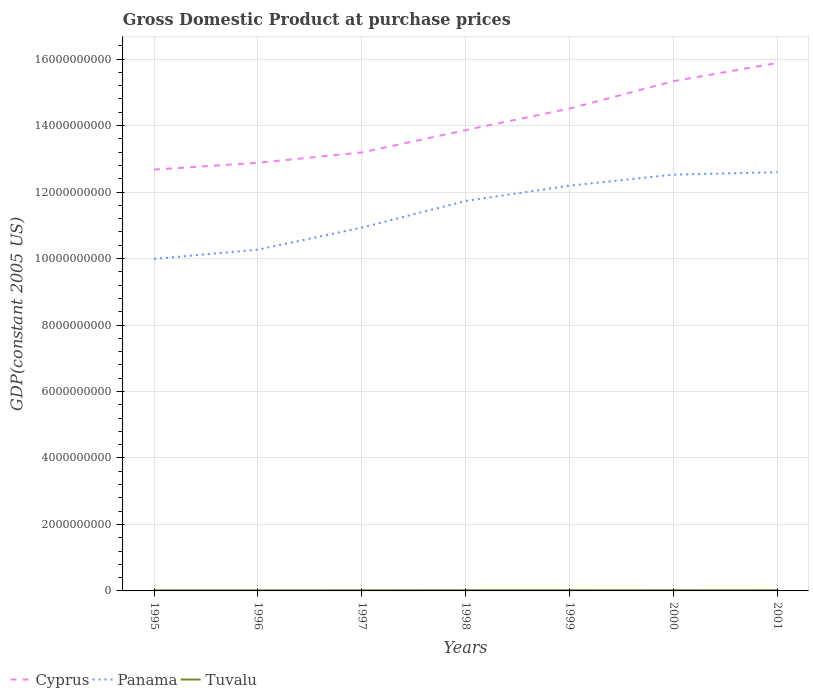How many different coloured lines are there?
Make the answer very short. 3. Across all years, what is the maximum GDP at purchase prices in Tuvalu?
Make the answer very short. 1.75e+07. In which year was the GDP at purchase prices in Cyprus maximum?
Your answer should be compact. 1995. What is the total GDP at purchase prices in Cyprus in the graph?
Your answer should be compact. -1.84e+09. What is the difference between the highest and the second highest GDP at purchase prices in Cyprus?
Your answer should be very brief. 3.21e+09. What is the difference between the highest and the lowest GDP at purchase prices in Cyprus?
Keep it short and to the point. 3. Is the GDP at purchase prices in Cyprus strictly greater than the GDP at purchase prices in Tuvalu over the years?
Provide a succinct answer. No. How many lines are there?
Make the answer very short. 3. How many years are there in the graph?
Your response must be concise. 7. Are the values on the major ticks of Y-axis written in scientific E-notation?
Offer a very short reply. No. Does the graph contain any zero values?
Offer a very short reply. No. Where does the legend appear in the graph?
Keep it short and to the point. Bottom left. What is the title of the graph?
Ensure brevity in your answer.  Gross Domestic Product at purchase prices. Does "Germany" appear as one of the legend labels in the graph?
Ensure brevity in your answer.  No. What is the label or title of the Y-axis?
Provide a short and direct response. GDP(constant 2005 US). What is the GDP(constant 2005 US) in Cyprus in 1995?
Provide a short and direct response. 1.27e+1. What is the GDP(constant 2005 US) of Panama in 1995?
Offer a very short reply. 9.99e+09. What is the GDP(constant 2005 US) of Tuvalu in 1995?
Your answer should be very brief. 1.86e+07. What is the GDP(constant 2005 US) in Cyprus in 1996?
Offer a terse response. 1.29e+1. What is the GDP(constant 2005 US) of Panama in 1996?
Your answer should be very brief. 1.03e+1. What is the GDP(constant 2005 US) in Tuvalu in 1996?
Give a very brief answer. 1.75e+07. What is the GDP(constant 2005 US) of Cyprus in 1997?
Provide a short and direct response. 1.32e+1. What is the GDP(constant 2005 US) of Panama in 1997?
Give a very brief answer. 1.09e+1. What is the GDP(constant 2005 US) in Tuvalu in 1997?
Provide a short and direct response. 1.93e+07. What is the GDP(constant 2005 US) of Cyprus in 1998?
Offer a very short reply. 1.39e+1. What is the GDP(constant 2005 US) in Panama in 1998?
Your answer should be very brief. 1.17e+1. What is the GDP(constant 2005 US) of Tuvalu in 1998?
Your response must be concise. 2.23e+07. What is the GDP(constant 2005 US) of Cyprus in 1999?
Offer a very short reply. 1.45e+1. What is the GDP(constant 2005 US) of Panama in 1999?
Provide a succinct answer. 1.22e+1. What is the GDP(constant 2005 US) of Tuvalu in 1999?
Ensure brevity in your answer.  2.19e+07. What is the GDP(constant 2005 US) in Cyprus in 2000?
Provide a succinct answer. 1.53e+1. What is the GDP(constant 2005 US) of Panama in 2000?
Make the answer very short. 1.25e+1. What is the GDP(constant 2005 US) of Tuvalu in 2000?
Offer a very short reply. 2.17e+07. What is the GDP(constant 2005 US) of Cyprus in 2001?
Provide a short and direct response. 1.59e+1. What is the GDP(constant 2005 US) in Panama in 2001?
Make the answer very short. 1.26e+1. What is the GDP(constant 2005 US) of Tuvalu in 2001?
Offer a terse response. 2.21e+07. Across all years, what is the maximum GDP(constant 2005 US) of Cyprus?
Make the answer very short. 1.59e+1. Across all years, what is the maximum GDP(constant 2005 US) in Panama?
Keep it short and to the point. 1.26e+1. Across all years, what is the maximum GDP(constant 2005 US) of Tuvalu?
Your response must be concise. 2.23e+07. Across all years, what is the minimum GDP(constant 2005 US) in Cyprus?
Provide a short and direct response. 1.27e+1. Across all years, what is the minimum GDP(constant 2005 US) in Panama?
Provide a short and direct response. 9.99e+09. Across all years, what is the minimum GDP(constant 2005 US) in Tuvalu?
Keep it short and to the point. 1.75e+07. What is the total GDP(constant 2005 US) in Cyprus in the graph?
Offer a terse response. 9.83e+1. What is the total GDP(constant 2005 US) of Panama in the graph?
Provide a short and direct response. 8.02e+1. What is the total GDP(constant 2005 US) of Tuvalu in the graph?
Give a very brief answer. 1.43e+08. What is the difference between the GDP(constant 2005 US) of Cyprus in 1995 and that in 1996?
Your answer should be very brief. -2.06e+08. What is the difference between the GDP(constant 2005 US) in Panama in 1995 and that in 1996?
Provide a succinct answer. -2.81e+08. What is the difference between the GDP(constant 2005 US) in Tuvalu in 1995 and that in 1996?
Your answer should be very brief. 1.11e+06. What is the difference between the GDP(constant 2005 US) in Cyprus in 1995 and that in 1997?
Offer a very short reply. -5.15e+08. What is the difference between the GDP(constant 2005 US) of Panama in 1995 and that in 1997?
Your answer should be compact. -9.44e+08. What is the difference between the GDP(constant 2005 US) in Tuvalu in 1995 and that in 1997?
Ensure brevity in your answer.  -6.42e+05. What is the difference between the GDP(constant 2005 US) in Cyprus in 1995 and that in 1998?
Your answer should be compact. -1.19e+09. What is the difference between the GDP(constant 2005 US) in Panama in 1995 and that in 1998?
Give a very brief answer. -1.75e+09. What is the difference between the GDP(constant 2005 US) in Tuvalu in 1995 and that in 1998?
Offer a very short reply. -3.63e+06. What is the difference between the GDP(constant 2005 US) of Cyprus in 1995 and that in 1999?
Keep it short and to the point. -1.84e+09. What is the difference between the GDP(constant 2005 US) of Panama in 1995 and that in 1999?
Keep it short and to the point. -2.21e+09. What is the difference between the GDP(constant 2005 US) of Tuvalu in 1995 and that in 1999?
Your response must be concise. -3.28e+06. What is the difference between the GDP(constant 2005 US) in Cyprus in 1995 and that in 2000?
Ensure brevity in your answer.  -2.66e+09. What is the difference between the GDP(constant 2005 US) in Panama in 1995 and that in 2000?
Offer a very short reply. -2.54e+09. What is the difference between the GDP(constant 2005 US) in Tuvalu in 1995 and that in 2000?
Offer a terse response. -3.07e+06. What is the difference between the GDP(constant 2005 US) of Cyprus in 1995 and that in 2001?
Make the answer very short. -3.21e+09. What is the difference between the GDP(constant 2005 US) of Panama in 1995 and that in 2001?
Give a very brief answer. -2.61e+09. What is the difference between the GDP(constant 2005 US) of Tuvalu in 1995 and that in 2001?
Offer a terse response. -3.42e+06. What is the difference between the GDP(constant 2005 US) of Cyprus in 1996 and that in 1997?
Your answer should be compact. -3.09e+08. What is the difference between the GDP(constant 2005 US) in Panama in 1996 and that in 1997?
Your answer should be compact. -6.63e+08. What is the difference between the GDP(constant 2005 US) of Tuvalu in 1996 and that in 1997?
Provide a succinct answer. -1.75e+06. What is the difference between the GDP(constant 2005 US) in Cyprus in 1996 and that in 1998?
Offer a very short reply. -9.81e+08. What is the difference between the GDP(constant 2005 US) in Panama in 1996 and that in 1998?
Offer a terse response. -1.47e+09. What is the difference between the GDP(constant 2005 US) in Tuvalu in 1996 and that in 1998?
Keep it short and to the point. -4.74e+06. What is the difference between the GDP(constant 2005 US) in Cyprus in 1996 and that in 1999?
Make the answer very short. -1.63e+09. What is the difference between the GDP(constant 2005 US) of Panama in 1996 and that in 1999?
Ensure brevity in your answer.  -1.93e+09. What is the difference between the GDP(constant 2005 US) of Tuvalu in 1996 and that in 1999?
Provide a succinct answer. -4.39e+06. What is the difference between the GDP(constant 2005 US) in Cyprus in 1996 and that in 2000?
Your answer should be compact. -2.45e+09. What is the difference between the GDP(constant 2005 US) of Panama in 1996 and that in 2000?
Provide a succinct answer. -2.26e+09. What is the difference between the GDP(constant 2005 US) of Tuvalu in 1996 and that in 2000?
Keep it short and to the point. -4.18e+06. What is the difference between the GDP(constant 2005 US) of Cyprus in 1996 and that in 2001?
Provide a succinct answer. -3.00e+09. What is the difference between the GDP(constant 2005 US) in Panama in 1996 and that in 2001?
Keep it short and to the point. -2.33e+09. What is the difference between the GDP(constant 2005 US) of Tuvalu in 1996 and that in 2001?
Offer a terse response. -4.54e+06. What is the difference between the GDP(constant 2005 US) in Cyprus in 1997 and that in 1998?
Offer a very short reply. -6.72e+08. What is the difference between the GDP(constant 2005 US) of Panama in 1997 and that in 1998?
Give a very brief answer. -8.02e+08. What is the difference between the GDP(constant 2005 US) in Tuvalu in 1997 and that in 1998?
Make the answer very short. -2.99e+06. What is the difference between the GDP(constant 2005 US) of Cyprus in 1997 and that in 1999?
Make the answer very short. -1.32e+09. What is the difference between the GDP(constant 2005 US) of Panama in 1997 and that in 1999?
Provide a short and direct response. -1.26e+09. What is the difference between the GDP(constant 2005 US) of Tuvalu in 1997 and that in 1999?
Provide a short and direct response. -2.64e+06. What is the difference between the GDP(constant 2005 US) in Cyprus in 1997 and that in 2000?
Provide a succinct answer. -2.14e+09. What is the difference between the GDP(constant 2005 US) in Panama in 1997 and that in 2000?
Offer a very short reply. -1.59e+09. What is the difference between the GDP(constant 2005 US) of Tuvalu in 1997 and that in 2000?
Your response must be concise. -2.43e+06. What is the difference between the GDP(constant 2005 US) in Cyprus in 1997 and that in 2001?
Offer a terse response. -2.69e+09. What is the difference between the GDP(constant 2005 US) in Panama in 1997 and that in 2001?
Your answer should be very brief. -1.67e+09. What is the difference between the GDP(constant 2005 US) in Tuvalu in 1997 and that in 2001?
Your answer should be very brief. -2.78e+06. What is the difference between the GDP(constant 2005 US) in Cyprus in 1998 and that in 1999?
Keep it short and to the point. -6.50e+08. What is the difference between the GDP(constant 2005 US) in Panama in 1998 and that in 1999?
Your response must be concise. -4.60e+08. What is the difference between the GDP(constant 2005 US) of Tuvalu in 1998 and that in 1999?
Provide a succinct answer. 3.48e+05. What is the difference between the GDP(constant 2005 US) in Cyprus in 1998 and that in 2000?
Ensure brevity in your answer.  -1.47e+09. What is the difference between the GDP(constant 2005 US) of Panama in 1998 and that in 2000?
Keep it short and to the point. -7.91e+08. What is the difference between the GDP(constant 2005 US) in Tuvalu in 1998 and that in 2000?
Your answer should be compact. 5.61e+05. What is the difference between the GDP(constant 2005 US) of Cyprus in 1998 and that in 2001?
Make the answer very short. -2.02e+09. What is the difference between the GDP(constant 2005 US) in Panama in 1998 and that in 2001?
Make the answer very short. -8.63e+08. What is the difference between the GDP(constant 2005 US) of Tuvalu in 1998 and that in 2001?
Offer a very short reply. 2.06e+05. What is the difference between the GDP(constant 2005 US) of Cyprus in 1999 and that in 2000?
Your response must be concise. -8.23e+08. What is the difference between the GDP(constant 2005 US) of Panama in 1999 and that in 2000?
Keep it short and to the point. -3.31e+08. What is the difference between the GDP(constant 2005 US) in Tuvalu in 1999 and that in 2000?
Your answer should be compact. 2.13e+05. What is the difference between the GDP(constant 2005 US) of Cyprus in 1999 and that in 2001?
Make the answer very short. -1.37e+09. What is the difference between the GDP(constant 2005 US) in Panama in 1999 and that in 2001?
Make the answer very short. -4.03e+08. What is the difference between the GDP(constant 2005 US) in Tuvalu in 1999 and that in 2001?
Provide a short and direct response. -1.42e+05. What is the difference between the GDP(constant 2005 US) of Cyprus in 2000 and that in 2001?
Your response must be concise. -5.48e+08. What is the difference between the GDP(constant 2005 US) of Panama in 2000 and that in 2001?
Your answer should be compact. -7.19e+07. What is the difference between the GDP(constant 2005 US) in Tuvalu in 2000 and that in 2001?
Offer a terse response. -3.55e+05. What is the difference between the GDP(constant 2005 US) in Cyprus in 1995 and the GDP(constant 2005 US) in Panama in 1996?
Keep it short and to the point. 2.41e+09. What is the difference between the GDP(constant 2005 US) in Cyprus in 1995 and the GDP(constant 2005 US) in Tuvalu in 1996?
Ensure brevity in your answer.  1.27e+1. What is the difference between the GDP(constant 2005 US) in Panama in 1995 and the GDP(constant 2005 US) in Tuvalu in 1996?
Keep it short and to the point. 9.97e+09. What is the difference between the GDP(constant 2005 US) in Cyprus in 1995 and the GDP(constant 2005 US) in Panama in 1997?
Your answer should be compact. 1.74e+09. What is the difference between the GDP(constant 2005 US) of Cyprus in 1995 and the GDP(constant 2005 US) of Tuvalu in 1997?
Your answer should be compact. 1.27e+1. What is the difference between the GDP(constant 2005 US) in Panama in 1995 and the GDP(constant 2005 US) in Tuvalu in 1997?
Your answer should be compact. 9.97e+09. What is the difference between the GDP(constant 2005 US) of Cyprus in 1995 and the GDP(constant 2005 US) of Panama in 1998?
Make the answer very short. 9.42e+08. What is the difference between the GDP(constant 2005 US) in Cyprus in 1995 and the GDP(constant 2005 US) in Tuvalu in 1998?
Provide a short and direct response. 1.27e+1. What is the difference between the GDP(constant 2005 US) of Panama in 1995 and the GDP(constant 2005 US) of Tuvalu in 1998?
Provide a succinct answer. 9.96e+09. What is the difference between the GDP(constant 2005 US) of Cyprus in 1995 and the GDP(constant 2005 US) of Panama in 1999?
Offer a very short reply. 4.83e+08. What is the difference between the GDP(constant 2005 US) of Cyprus in 1995 and the GDP(constant 2005 US) of Tuvalu in 1999?
Your answer should be very brief. 1.27e+1. What is the difference between the GDP(constant 2005 US) in Panama in 1995 and the GDP(constant 2005 US) in Tuvalu in 1999?
Your answer should be very brief. 9.96e+09. What is the difference between the GDP(constant 2005 US) of Cyprus in 1995 and the GDP(constant 2005 US) of Panama in 2000?
Your response must be concise. 1.52e+08. What is the difference between the GDP(constant 2005 US) in Cyprus in 1995 and the GDP(constant 2005 US) in Tuvalu in 2000?
Provide a short and direct response. 1.27e+1. What is the difference between the GDP(constant 2005 US) of Panama in 1995 and the GDP(constant 2005 US) of Tuvalu in 2000?
Give a very brief answer. 9.96e+09. What is the difference between the GDP(constant 2005 US) of Cyprus in 1995 and the GDP(constant 2005 US) of Panama in 2001?
Provide a short and direct response. 7.97e+07. What is the difference between the GDP(constant 2005 US) of Cyprus in 1995 and the GDP(constant 2005 US) of Tuvalu in 2001?
Provide a succinct answer. 1.27e+1. What is the difference between the GDP(constant 2005 US) in Panama in 1995 and the GDP(constant 2005 US) in Tuvalu in 2001?
Provide a short and direct response. 9.96e+09. What is the difference between the GDP(constant 2005 US) of Cyprus in 1996 and the GDP(constant 2005 US) of Panama in 1997?
Offer a very short reply. 1.95e+09. What is the difference between the GDP(constant 2005 US) in Cyprus in 1996 and the GDP(constant 2005 US) in Tuvalu in 1997?
Make the answer very short. 1.29e+1. What is the difference between the GDP(constant 2005 US) in Panama in 1996 and the GDP(constant 2005 US) in Tuvalu in 1997?
Your answer should be very brief. 1.02e+1. What is the difference between the GDP(constant 2005 US) of Cyprus in 1996 and the GDP(constant 2005 US) of Panama in 1998?
Give a very brief answer. 1.15e+09. What is the difference between the GDP(constant 2005 US) in Cyprus in 1996 and the GDP(constant 2005 US) in Tuvalu in 1998?
Provide a short and direct response. 1.29e+1. What is the difference between the GDP(constant 2005 US) in Panama in 1996 and the GDP(constant 2005 US) in Tuvalu in 1998?
Your answer should be compact. 1.02e+1. What is the difference between the GDP(constant 2005 US) of Cyprus in 1996 and the GDP(constant 2005 US) of Panama in 1999?
Provide a short and direct response. 6.89e+08. What is the difference between the GDP(constant 2005 US) of Cyprus in 1996 and the GDP(constant 2005 US) of Tuvalu in 1999?
Give a very brief answer. 1.29e+1. What is the difference between the GDP(constant 2005 US) of Panama in 1996 and the GDP(constant 2005 US) of Tuvalu in 1999?
Offer a very short reply. 1.02e+1. What is the difference between the GDP(constant 2005 US) of Cyprus in 1996 and the GDP(constant 2005 US) of Panama in 2000?
Offer a terse response. 3.58e+08. What is the difference between the GDP(constant 2005 US) of Cyprus in 1996 and the GDP(constant 2005 US) of Tuvalu in 2000?
Provide a short and direct response. 1.29e+1. What is the difference between the GDP(constant 2005 US) of Panama in 1996 and the GDP(constant 2005 US) of Tuvalu in 2000?
Give a very brief answer. 1.02e+1. What is the difference between the GDP(constant 2005 US) in Cyprus in 1996 and the GDP(constant 2005 US) in Panama in 2001?
Ensure brevity in your answer.  2.86e+08. What is the difference between the GDP(constant 2005 US) in Cyprus in 1996 and the GDP(constant 2005 US) in Tuvalu in 2001?
Ensure brevity in your answer.  1.29e+1. What is the difference between the GDP(constant 2005 US) in Panama in 1996 and the GDP(constant 2005 US) in Tuvalu in 2001?
Offer a very short reply. 1.02e+1. What is the difference between the GDP(constant 2005 US) of Cyprus in 1997 and the GDP(constant 2005 US) of Panama in 1998?
Ensure brevity in your answer.  1.46e+09. What is the difference between the GDP(constant 2005 US) of Cyprus in 1997 and the GDP(constant 2005 US) of Tuvalu in 1998?
Your response must be concise. 1.32e+1. What is the difference between the GDP(constant 2005 US) in Panama in 1997 and the GDP(constant 2005 US) in Tuvalu in 1998?
Give a very brief answer. 1.09e+1. What is the difference between the GDP(constant 2005 US) of Cyprus in 1997 and the GDP(constant 2005 US) of Panama in 1999?
Provide a succinct answer. 9.98e+08. What is the difference between the GDP(constant 2005 US) of Cyprus in 1997 and the GDP(constant 2005 US) of Tuvalu in 1999?
Make the answer very short. 1.32e+1. What is the difference between the GDP(constant 2005 US) in Panama in 1997 and the GDP(constant 2005 US) in Tuvalu in 1999?
Ensure brevity in your answer.  1.09e+1. What is the difference between the GDP(constant 2005 US) in Cyprus in 1997 and the GDP(constant 2005 US) in Panama in 2000?
Your answer should be very brief. 6.67e+08. What is the difference between the GDP(constant 2005 US) of Cyprus in 1997 and the GDP(constant 2005 US) of Tuvalu in 2000?
Ensure brevity in your answer.  1.32e+1. What is the difference between the GDP(constant 2005 US) in Panama in 1997 and the GDP(constant 2005 US) in Tuvalu in 2000?
Provide a succinct answer. 1.09e+1. What is the difference between the GDP(constant 2005 US) in Cyprus in 1997 and the GDP(constant 2005 US) in Panama in 2001?
Ensure brevity in your answer.  5.95e+08. What is the difference between the GDP(constant 2005 US) in Cyprus in 1997 and the GDP(constant 2005 US) in Tuvalu in 2001?
Make the answer very short. 1.32e+1. What is the difference between the GDP(constant 2005 US) of Panama in 1997 and the GDP(constant 2005 US) of Tuvalu in 2001?
Keep it short and to the point. 1.09e+1. What is the difference between the GDP(constant 2005 US) of Cyprus in 1998 and the GDP(constant 2005 US) of Panama in 1999?
Give a very brief answer. 1.67e+09. What is the difference between the GDP(constant 2005 US) of Cyprus in 1998 and the GDP(constant 2005 US) of Tuvalu in 1999?
Keep it short and to the point. 1.38e+1. What is the difference between the GDP(constant 2005 US) in Panama in 1998 and the GDP(constant 2005 US) in Tuvalu in 1999?
Your answer should be very brief. 1.17e+1. What is the difference between the GDP(constant 2005 US) of Cyprus in 1998 and the GDP(constant 2005 US) of Panama in 2000?
Your answer should be very brief. 1.34e+09. What is the difference between the GDP(constant 2005 US) of Cyprus in 1998 and the GDP(constant 2005 US) of Tuvalu in 2000?
Your answer should be very brief. 1.38e+1. What is the difference between the GDP(constant 2005 US) of Panama in 1998 and the GDP(constant 2005 US) of Tuvalu in 2000?
Ensure brevity in your answer.  1.17e+1. What is the difference between the GDP(constant 2005 US) of Cyprus in 1998 and the GDP(constant 2005 US) of Panama in 2001?
Ensure brevity in your answer.  1.27e+09. What is the difference between the GDP(constant 2005 US) in Cyprus in 1998 and the GDP(constant 2005 US) in Tuvalu in 2001?
Your response must be concise. 1.38e+1. What is the difference between the GDP(constant 2005 US) in Panama in 1998 and the GDP(constant 2005 US) in Tuvalu in 2001?
Your answer should be compact. 1.17e+1. What is the difference between the GDP(constant 2005 US) in Cyprus in 1999 and the GDP(constant 2005 US) in Panama in 2000?
Keep it short and to the point. 1.99e+09. What is the difference between the GDP(constant 2005 US) in Cyprus in 1999 and the GDP(constant 2005 US) in Tuvalu in 2000?
Offer a terse response. 1.45e+1. What is the difference between the GDP(constant 2005 US) of Panama in 1999 and the GDP(constant 2005 US) of Tuvalu in 2000?
Your answer should be compact. 1.22e+1. What is the difference between the GDP(constant 2005 US) in Cyprus in 1999 and the GDP(constant 2005 US) in Panama in 2001?
Provide a short and direct response. 1.92e+09. What is the difference between the GDP(constant 2005 US) of Cyprus in 1999 and the GDP(constant 2005 US) of Tuvalu in 2001?
Offer a terse response. 1.45e+1. What is the difference between the GDP(constant 2005 US) in Panama in 1999 and the GDP(constant 2005 US) in Tuvalu in 2001?
Offer a very short reply. 1.22e+1. What is the difference between the GDP(constant 2005 US) of Cyprus in 2000 and the GDP(constant 2005 US) of Panama in 2001?
Keep it short and to the point. 2.74e+09. What is the difference between the GDP(constant 2005 US) of Cyprus in 2000 and the GDP(constant 2005 US) of Tuvalu in 2001?
Provide a short and direct response. 1.53e+1. What is the difference between the GDP(constant 2005 US) of Panama in 2000 and the GDP(constant 2005 US) of Tuvalu in 2001?
Make the answer very short. 1.25e+1. What is the average GDP(constant 2005 US) of Cyprus per year?
Provide a short and direct response. 1.40e+1. What is the average GDP(constant 2005 US) of Panama per year?
Provide a succinct answer. 1.15e+1. What is the average GDP(constant 2005 US) of Tuvalu per year?
Your answer should be compact. 2.05e+07. In the year 1995, what is the difference between the GDP(constant 2005 US) of Cyprus and GDP(constant 2005 US) of Panama?
Your answer should be compact. 2.69e+09. In the year 1995, what is the difference between the GDP(constant 2005 US) in Cyprus and GDP(constant 2005 US) in Tuvalu?
Give a very brief answer. 1.27e+1. In the year 1995, what is the difference between the GDP(constant 2005 US) in Panama and GDP(constant 2005 US) in Tuvalu?
Give a very brief answer. 9.97e+09. In the year 1996, what is the difference between the GDP(constant 2005 US) of Cyprus and GDP(constant 2005 US) of Panama?
Your answer should be compact. 2.61e+09. In the year 1996, what is the difference between the GDP(constant 2005 US) of Cyprus and GDP(constant 2005 US) of Tuvalu?
Your response must be concise. 1.29e+1. In the year 1996, what is the difference between the GDP(constant 2005 US) in Panama and GDP(constant 2005 US) in Tuvalu?
Ensure brevity in your answer.  1.02e+1. In the year 1997, what is the difference between the GDP(constant 2005 US) of Cyprus and GDP(constant 2005 US) of Panama?
Make the answer very short. 2.26e+09. In the year 1997, what is the difference between the GDP(constant 2005 US) of Cyprus and GDP(constant 2005 US) of Tuvalu?
Provide a succinct answer. 1.32e+1. In the year 1997, what is the difference between the GDP(constant 2005 US) of Panama and GDP(constant 2005 US) of Tuvalu?
Offer a very short reply. 1.09e+1. In the year 1998, what is the difference between the GDP(constant 2005 US) in Cyprus and GDP(constant 2005 US) in Panama?
Offer a very short reply. 2.13e+09. In the year 1998, what is the difference between the GDP(constant 2005 US) of Cyprus and GDP(constant 2005 US) of Tuvalu?
Your answer should be very brief. 1.38e+1. In the year 1998, what is the difference between the GDP(constant 2005 US) in Panama and GDP(constant 2005 US) in Tuvalu?
Your response must be concise. 1.17e+1. In the year 1999, what is the difference between the GDP(constant 2005 US) in Cyprus and GDP(constant 2005 US) in Panama?
Offer a terse response. 2.32e+09. In the year 1999, what is the difference between the GDP(constant 2005 US) of Cyprus and GDP(constant 2005 US) of Tuvalu?
Keep it short and to the point. 1.45e+1. In the year 1999, what is the difference between the GDP(constant 2005 US) of Panama and GDP(constant 2005 US) of Tuvalu?
Provide a succinct answer. 1.22e+1. In the year 2000, what is the difference between the GDP(constant 2005 US) of Cyprus and GDP(constant 2005 US) of Panama?
Give a very brief answer. 2.81e+09. In the year 2000, what is the difference between the GDP(constant 2005 US) in Cyprus and GDP(constant 2005 US) in Tuvalu?
Offer a very short reply. 1.53e+1. In the year 2000, what is the difference between the GDP(constant 2005 US) of Panama and GDP(constant 2005 US) of Tuvalu?
Your response must be concise. 1.25e+1. In the year 2001, what is the difference between the GDP(constant 2005 US) of Cyprus and GDP(constant 2005 US) of Panama?
Ensure brevity in your answer.  3.29e+09. In the year 2001, what is the difference between the GDP(constant 2005 US) in Cyprus and GDP(constant 2005 US) in Tuvalu?
Provide a short and direct response. 1.59e+1. In the year 2001, what is the difference between the GDP(constant 2005 US) of Panama and GDP(constant 2005 US) of Tuvalu?
Your answer should be very brief. 1.26e+1. What is the ratio of the GDP(constant 2005 US) in Cyprus in 1995 to that in 1996?
Your response must be concise. 0.98. What is the ratio of the GDP(constant 2005 US) of Panama in 1995 to that in 1996?
Offer a terse response. 0.97. What is the ratio of the GDP(constant 2005 US) of Tuvalu in 1995 to that in 1996?
Offer a terse response. 1.06. What is the ratio of the GDP(constant 2005 US) in Cyprus in 1995 to that in 1997?
Ensure brevity in your answer.  0.96. What is the ratio of the GDP(constant 2005 US) in Panama in 1995 to that in 1997?
Provide a short and direct response. 0.91. What is the ratio of the GDP(constant 2005 US) of Tuvalu in 1995 to that in 1997?
Offer a terse response. 0.97. What is the ratio of the GDP(constant 2005 US) of Cyprus in 1995 to that in 1998?
Your response must be concise. 0.91. What is the ratio of the GDP(constant 2005 US) in Panama in 1995 to that in 1998?
Offer a terse response. 0.85. What is the ratio of the GDP(constant 2005 US) in Tuvalu in 1995 to that in 1998?
Make the answer very short. 0.84. What is the ratio of the GDP(constant 2005 US) in Cyprus in 1995 to that in 1999?
Make the answer very short. 0.87. What is the ratio of the GDP(constant 2005 US) of Panama in 1995 to that in 1999?
Keep it short and to the point. 0.82. What is the ratio of the GDP(constant 2005 US) in Tuvalu in 1995 to that in 1999?
Your answer should be very brief. 0.85. What is the ratio of the GDP(constant 2005 US) of Cyprus in 1995 to that in 2000?
Provide a short and direct response. 0.83. What is the ratio of the GDP(constant 2005 US) of Panama in 1995 to that in 2000?
Offer a very short reply. 0.8. What is the ratio of the GDP(constant 2005 US) of Tuvalu in 1995 to that in 2000?
Ensure brevity in your answer.  0.86. What is the ratio of the GDP(constant 2005 US) in Cyprus in 1995 to that in 2001?
Offer a very short reply. 0.8. What is the ratio of the GDP(constant 2005 US) in Panama in 1995 to that in 2001?
Give a very brief answer. 0.79. What is the ratio of the GDP(constant 2005 US) in Tuvalu in 1995 to that in 2001?
Offer a very short reply. 0.84. What is the ratio of the GDP(constant 2005 US) in Cyprus in 1996 to that in 1997?
Your answer should be very brief. 0.98. What is the ratio of the GDP(constant 2005 US) in Panama in 1996 to that in 1997?
Keep it short and to the point. 0.94. What is the ratio of the GDP(constant 2005 US) in Tuvalu in 1996 to that in 1997?
Ensure brevity in your answer.  0.91. What is the ratio of the GDP(constant 2005 US) in Cyprus in 1996 to that in 1998?
Provide a succinct answer. 0.93. What is the ratio of the GDP(constant 2005 US) of Panama in 1996 to that in 1998?
Provide a short and direct response. 0.88. What is the ratio of the GDP(constant 2005 US) in Tuvalu in 1996 to that in 1998?
Offer a very short reply. 0.79. What is the ratio of the GDP(constant 2005 US) in Cyprus in 1996 to that in 1999?
Ensure brevity in your answer.  0.89. What is the ratio of the GDP(constant 2005 US) in Panama in 1996 to that in 1999?
Make the answer very short. 0.84. What is the ratio of the GDP(constant 2005 US) in Tuvalu in 1996 to that in 1999?
Give a very brief answer. 0.8. What is the ratio of the GDP(constant 2005 US) of Cyprus in 1996 to that in 2000?
Your response must be concise. 0.84. What is the ratio of the GDP(constant 2005 US) in Panama in 1996 to that in 2000?
Your answer should be very brief. 0.82. What is the ratio of the GDP(constant 2005 US) in Tuvalu in 1996 to that in 2000?
Offer a very short reply. 0.81. What is the ratio of the GDP(constant 2005 US) in Cyprus in 1996 to that in 2001?
Make the answer very short. 0.81. What is the ratio of the GDP(constant 2005 US) in Panama in 1996 to that in 2001?
Ensure brevity in your answer.  0.82. What is the ratio of the GDP(constant 2005 US) in Tuvalu in 1996 to that in 2001?
Your answer should be very brief. 0.79. What is the ratio of the GDP(constant 2005 US) of Cyprus in 1997 to that in 1998?
Offer a terse response. 0.95. What is the ratio of the GDP(constant 2005 US) in Panama in 1997 to that in 1998?
Your answer should be compact. 0.93. What is the ratio of the GDP(constant 2005 US) in Tuvalu in 1997 to that in 1998?
Offer a terse response. 0.87. What is the ratio of the GDP(constant 2005 US) of Cyprus in 1997 to that in 1999?
Your response must be concise. 0.91. What is the ratio of the GDP(constant 2005 US) in Panama in 1997 to that in 1999?
Provide a short and direct response. 0.9. What is the ratio of the GDP(constant 2005 US) in Tuvalu in 1997 to that in 1999?
Your answer should be very brief. 0.88. What is the ratio of the GDP(constant 2005 US) of Cyprus in 1997 to that in 2000?
Provide a short and direct response. 0.86. What is the ratio of the GDP(constant 2005 US) in Panama in 1997 to that in 2000?
Offer a terse response. 0.87. What is the ratio of the GDP(constant 2005 US) in Tuvalu in 1997 to that in 2000?
Provide a succinct answer. 0.89. What is the ratio of the GDP(constant 2005 US) of Cyprus in 1997 to that in 2001?
Your answer should be compact. 0.83. What is the ratio of the GDP(constant 2005 US) in Panama in 1997 to that in 2001?
Offer a very short reply. 0.87. What is the ratio of the GDP(constant 2005 US) in Tuvalu in 1997 to that in 2001?
Make the answer very short. 0.87. What is the ratio of the GDP(constant 2005 US) of Cyprus in 1998 to that in 1999?
Provide a short and direct response. 0.96. What is the ratio of the GDP(constant 2005 US) of Panama in 1998 to that in 1999?
Offer a terse response. 0.96. What is the ratio of the GDP(constant 2005 US) in Tuvalu in 1998 to that in 1999?
Ensure brevity in your answer.  1.02. What is the ratio of the GDP(constant 2005 US) in Cyprus in 1998 to that in 2000?
Keep it short and to the point. 0.9. What is the ratio of the GDP(constant 2005 US) in Panama in 1998 to that in 2000?
Ensure brevity in your answer.  0.94. What is the ratio of the GDP(constant 2005 US) of Tuvalu in 1998 to that in 2000?
Provide a short and direct response. 1.03. What is the ratio of the GDP(constant 2005 US) in Cyprus in 1998 to that in 2001?
Keep it short and to the point. 0.87. What is the ratio of the GDP(constant 2005 US) in Panama in 1998 to that in 2001?
Offer a terse response. 0.93. What is the ratio of the GDP(constant 2005 US) of Tuvalu in 1998 to that in 2001?
Your response must be concise. 1.01. What is the ratio of the GDP(constant 2005 US) in Cyprus in 1999 to that in 2000?
Your answer should be compact. 0.95. What is the ratio of the GDP(constant 2005 US) in Panama in 1999 to that in 2000?
Give a very brief answer. 0.97. What is the ratio of the GDP(constant 2005 US) in Tuvalu in 1999 to that in 2000?
Provide a succinct answer. 1.01. What is the ratio of the GDP(constant 2005 US) of Cyprus in 1999 to that in 2001?
Your response must be concise. 0.91. What is the ratio of the GDP(constant 2005 US) in Panama in 1999 to that in 2001?
Offer a terse response. 0.97. What is the ratio of the GDP(constant 2005 US) in Tuvalu in 1999 to that in 2001?
Give a very brief answer. 0.99. What is the ratio of the GDP(constant 2005 US) of Cyprus in 2000 to that in 2001?
Your answer should be compact. 0.97. What is the ratio of the GDP(constant 2005 US) of Tuvalu in 2000 to that in 2001?
Offer a terse response. 0.98. What is the difference between the highest and the second highest GDP(constant 2005 US) in Cyprus?
Give a very brief answer. 5.48e+08. What is the difference between the highest and the second highest GDP(constant 2005 US) in Panama?
Make the answer very short. 7.19e+07. What is the difference between the highest and the second highest GDP(constant 2005 US) of Tuvalu?
Provide a short and direct response. 2.06e+05. What is the difference between the highest and the lowest GDP(constant 2005 US) of Cyprus?
Provide a short and direct response. 3.21e+09. What is the difference between the highest and the lowest GDP(constant 2005 US) of Panama?
Make the answer very short. 2.61e+09. What is the difference between the highest and the lowest GDP(constant 2005 US) of Tuvalu?
Provide a succinct answer. 4.74e+06. 